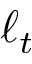<formula> <loc_0><loc_0><loc_500><loc_500>\ell _ { t }</formula> 